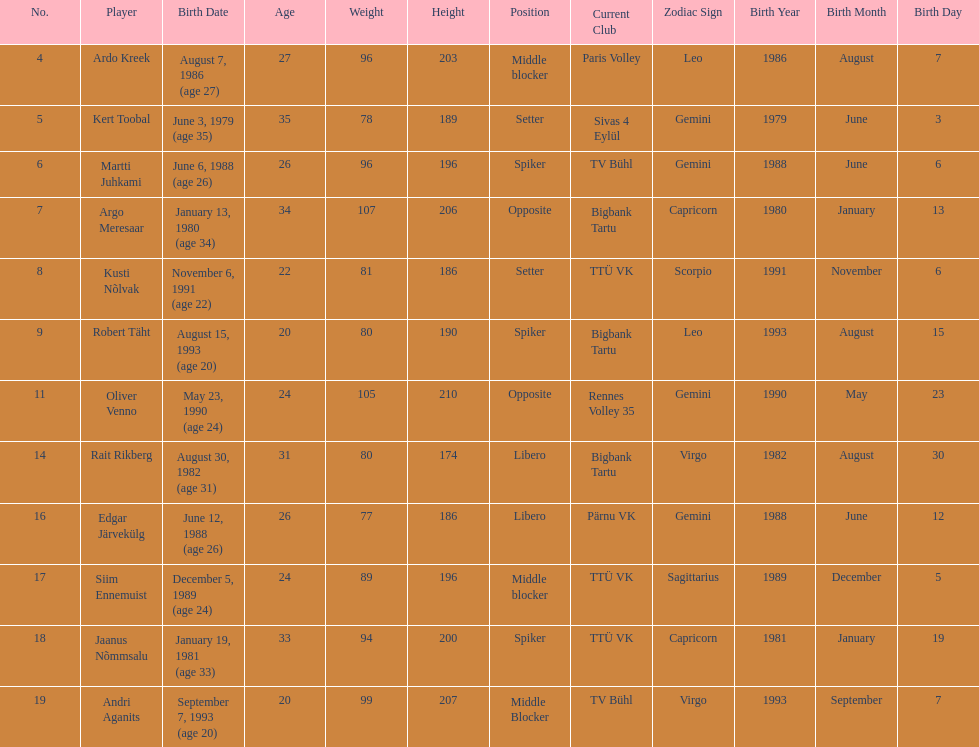How much taller in oliver venno than rait rikberg? 36. 